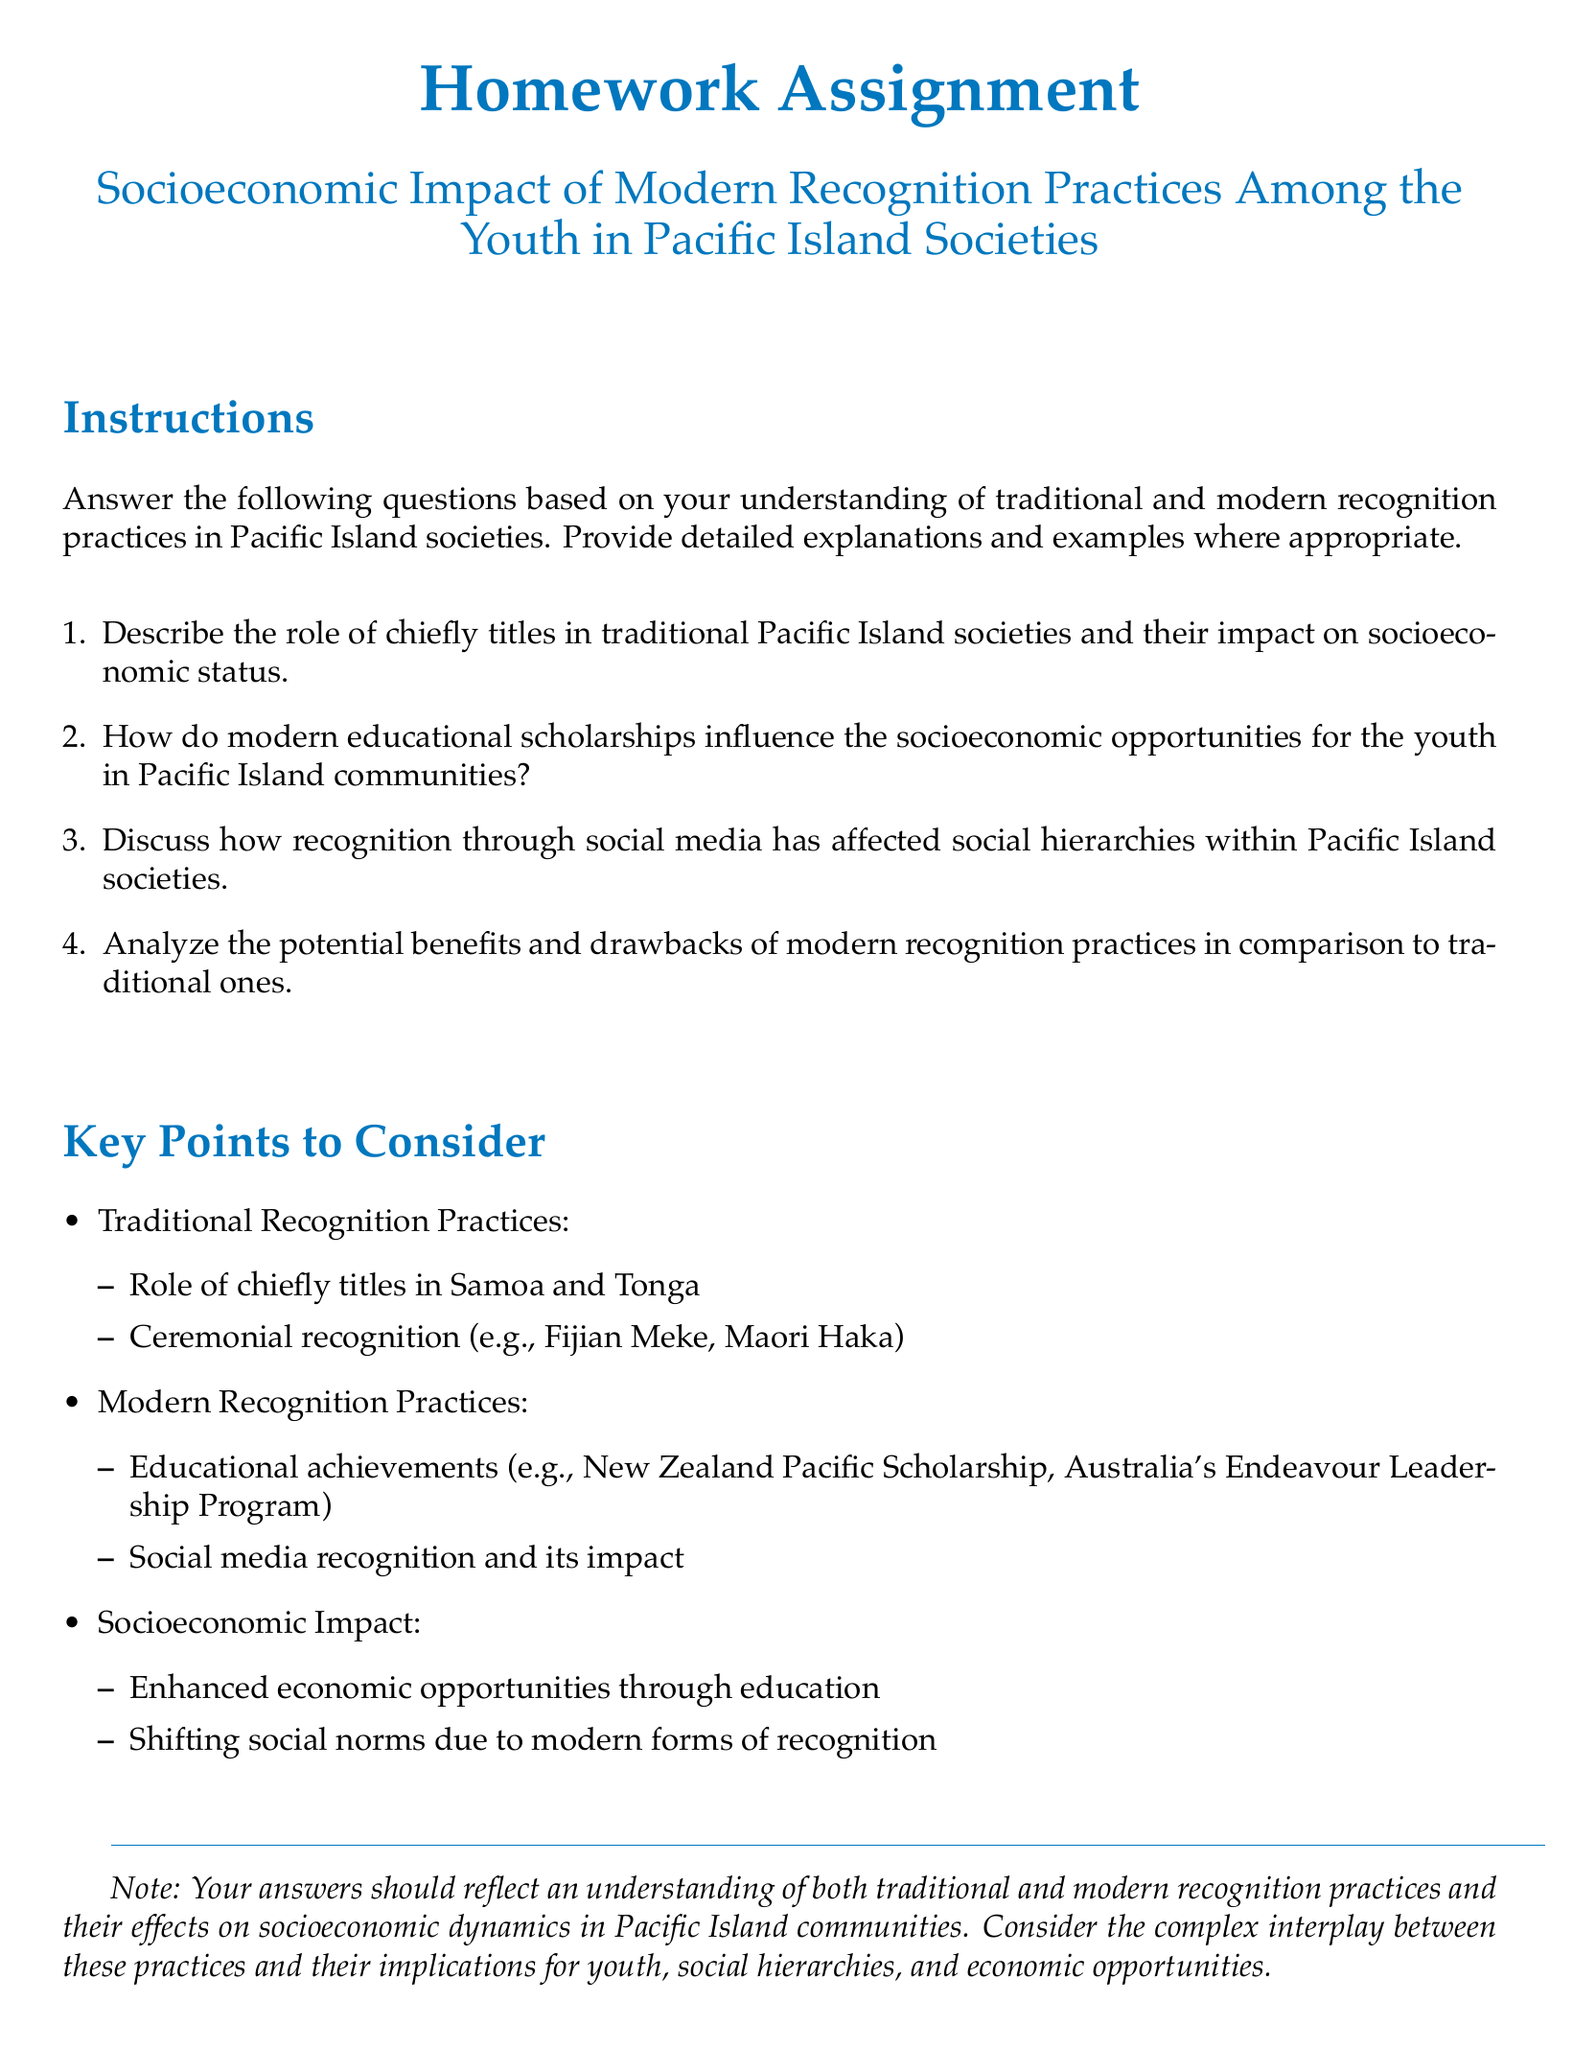what is the title of the homework assignment? The title of the homework assignment is specifically mentioned at the beginning of the document.
Answer: Socioeconomic Impact of Modern Recognition Practices Among the Youth in Pacific Island Societies how many main questions are in the assignment? The main questions are listed in an enumerated format, which indicates that there are a total of four questions.
Answer: 4 what is one example of a modern recognition practice mentioned? The document includes a list under modern recognition practices that gives specific examples of current recognition methods.
Answer: Educational achievements which Pacific Island societies are noted for chiefly titles? The document references specific societies known for chiefly titles within traditional recognition practices.
Answer: Samoa and Tonga name one traditional recognition practice mentioned. Traditional recognition practices such as specific ceremonies are mentioned in the document.
Answer: Fijian Meke what is the consequence of social media recognition as discussed in the document? The document highlights that social media influences social hierarchies within Pacific Island societies.
Answer: Affected social hierarchies how are educational scholarships described in relation to youth opportunities? The document discusses how educational scholarships provide socioeconomic opportunities for the youth in communities.
Answer: Influence opportunities what do modern recognition practices contrast with in the document? The document outlines a comparison between modern recognition practices and older systems of acknowledgment.
Answer: Traditional ones 